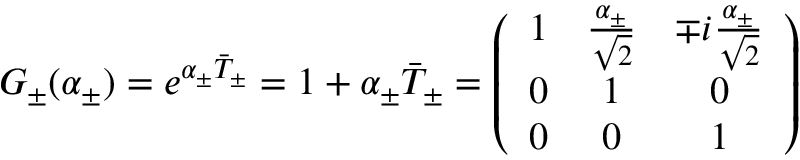Convert formula to latex. <formula><loc_0><loc_0><loc_500><loc_500>G _ { \pm } ( \alpha _ { \pm } ) = e ^ { \alpha _ { \pm } \bar { T } _ { \pm } } = 1 + \alpha _ { \pm } \bar { T } _ { \pm } = \left ( \begin{array} { c c c } { 1 } & { { \frac { \alpha _ { \pm } } { \sqrt { 2 } } } } & { { \mp i \frac { \alpha _ { \pm } } { \sqrt { 2 } } } } \\ { 0 } & { 1 } & { 0 } \\ { 0 } & { 0 } & { 1 } \end{array} \right )</formula> 